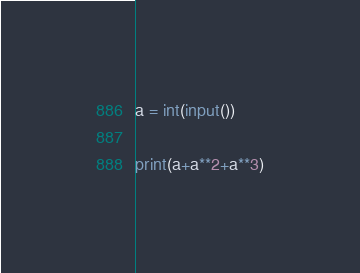<code> <loc_0><loc_0><loc_500><loc_500><_Python_>a = int(input())

print(a+a**2+a**3)</code> 